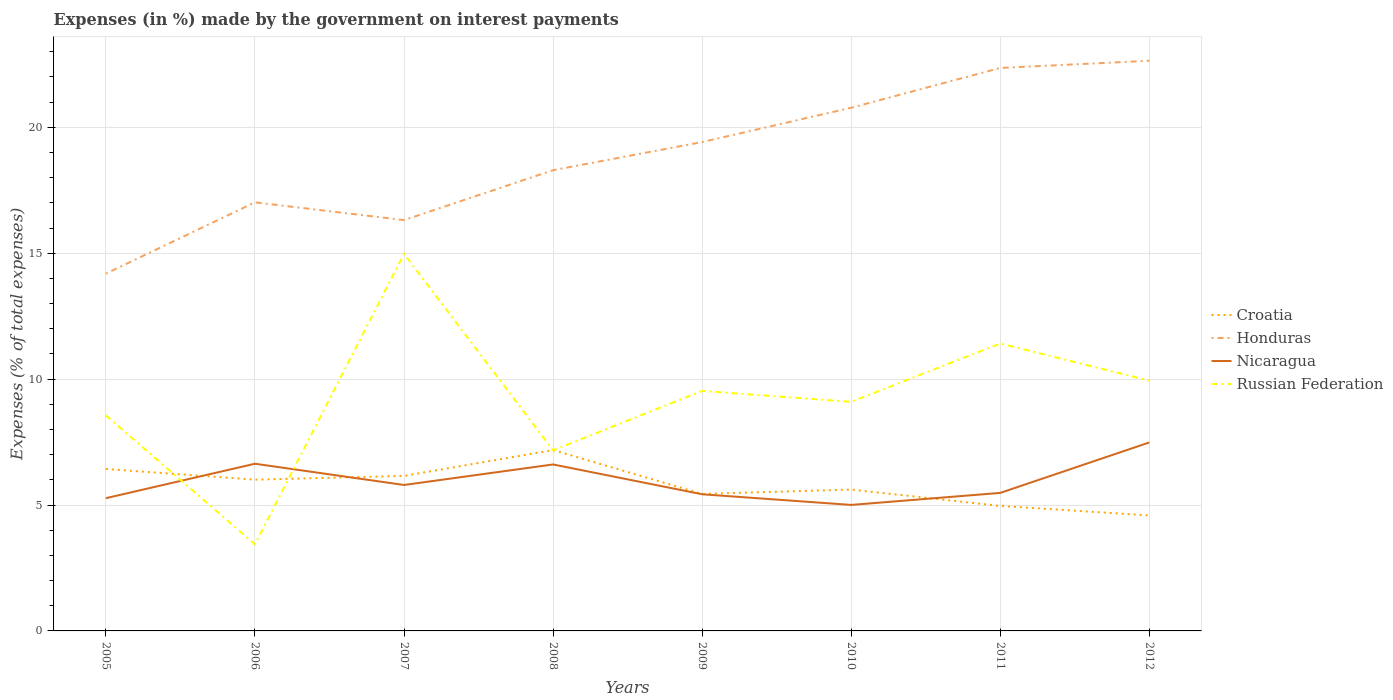How many different coloured lines are there?
Your response must be concise. 4. Is the number of lines equal to the number of legend labels?
Your answer should be compact. Yes. Across all years, what is the maximum percentage of expenses made by the government on interest payments in Croatia?
Ensure brevity in your answer.  4.59. What is the total percentage of expenses made by the government on interest payments in Honduras in the graph?
Your response must be concise. -4.06. What is the difference between the highest and the second highest percentage of expenses made by the government on interest payments in Croatia?
Offer a terse response. 2.6. What is the difference between the highest and the lowest percentage of expenses made by the government on interest payments in Honduras?
Offer a terse response. 4. Is the percentage of expenses made by the government on interest payments in Honduras strictly greater than the percentage of expenses made by the government on interest payments in Nicaragua over the years?
Your answer should be compact. No. How many lines are there?
Offer a terse response. 4. How many years are there in the graph?
Offer a terse response. 8. What is the difference between two consecutive major ticks on the Y-axis?
Offer a very short reply. 5. Are the values on the major ticks of Y-axis written in scientific E-notation?
Your response must be concise. No. How many legend labels are there?
Ensure brevity in your answer.  4. What is the title of the graph?
Make the answer very short. Expenses (in %) made by the government on interest payments. Does "Cuba" appear as one of the legend labels in the graph?
Give a very brief answer. No. What is the label or title of the Y-axis?
Your answer should be compact. Expenses (% of total expenses). What is the Expenses (% of total expenses) in Croatia in 2005?
Your answer should be very brief. 6.43. What is the Expenses (% of total expenses) of Honduras in 2005?
Your answer should be very brief. 14.19. What is the Expenses (% of total expenses) in Nicaragua in 2005?
Keep it short and to the point. 5.27. What is the Expenses (% of total expenses) of Russian Federation in 2005?
Your answer should be very brief. 8.56. What is the Expenses (% of total expenses) in Croatia in 2006?
Ensure brevity in your answer.  6.01. What is the Expenses (% of total expenses) of Honduras in 2006?
Provide a short and direct response. 17.02. What is the Expenses (% of total expenses) of Nicaragua in 2006?
Provide a succinct answer. 6.64. What is the Expenses (% of total expenses) in Russian Federation in 2006?
Your response must be concise. 3.44. What is the Expenses (% of total expenses) of Croatia in 2007?
Offer a terse response. 6.16. What is the Expenses (% of total expenses) in Honduras in 2007?
Offer a terse response. 16.32. What is the Expenses (% of total expenses) of Nicaragua in 2007?
Provide a short and direct response. 5.8. What is the Expenses (% of total expenses) in Russian Federation in 2007?
Your answer should be very brief. 14.98. What is the Expenses (% of total expenses) in Croatia in 2008?
Your answer should be compact. 7.18. What is the Expenses (% of total expenses) of Honduras in 2008?
Offer a terse response. 18.3. What is the Expenses (% of total expenses) of Nicaragua in 2008?
Your answer should be compact. 6.61. What is the Expenses (% of total expenses) in Russian Federation in 2008?
Give a very brief answer. 7.17. What is the Expenses (% of total expenses) of Croatia in 2009?
Your answer should be very brief. 5.44. What is the Expenses (% of total expenses) in Honduras in 2009?
Offer a very short reply. 19.42. What is the Expenses (% of total expenses) in Nicaragua in 2009?
Your response must be concise. 5.43. What is the Expenses (% of total expenses) in Russian Federation in 2009?
Keep it short and to the point. 9.53. What is the Expenses (% of total expenses) of Croatia in 2010?
Offer a terse response. 5.61. What is the Expenses (% of total expenses) of Honduras in 2010?
Offer a terse response. 20.78. What is the Expenses (% of total expenses) of Nicaragua in 2010?
Provide a short and direct response. 5. What is the Expenses (% of total expenses) in Russian Federation in 2010?
Give a very brief answer. 9.1. What is the Expenses (% of total expenses) in Croatia in 2011?
Offer a very short reply. 4.96. What is the Expenses (% of total expenses) in Honduras in 2011?
Provide a succinct answer. 22.36. What is the Expenses (% of total expenses) of Nicaragua in 2011?
Your answer should be compact. 5.48. What is the Expenses (% of total expenses) of Russian Federation in 2011?
Your answer should be compact. 11.41. What is the Expenses (% of total expenses) of Croatia in 2012?
Give a very brief answer. 4.59. What is the Expenses (% of total expenses) in Honduras in 2012?
Ensure brevity in your answer.  22.64. What is the Expenses (% of total expenses) in Nicaragua in 2012?
Offer a very short reply. 7.49. What is the Expenses (% of total expenses) in Russian Federation in 2012?
Keep it short and to the point. 9.94. Across all years, what is the maximum Expenses (% of total expenses) in Croatia?
Provide a succinct answer. 7.18. Across all years, what is the maximum Expenses (% of total expenses) of Honduras?
Give a very brief answer. 22.64. Across all years, what is the maximum Expenses (% of total expenses) of Nicaragua?
Give a very brief answer. 7.49. Across all years, what is the maximum Expenses (% of total expenses) of Russian Federation?
Offer a very short reply. 14.98. Across all years, what is the minimum Expenses (% of total expenses) of Croatia?
Make the answer very short. 4.59. Across all years, what is the minimum Expenses (% of total expenses) of Honduras?
Your response must be concise. 14.19. Across all years, what is the minimum Expenses (% of total expenses) of Nicaragua?
Ensure brevity in your answer.  5. Across all years, what is the minimum Expenses (% of total expenses) of Russian Federation?
Your answer should be compact. 3.44. What is the total Expenses (% of total expenses) of Croatia in the graph?
Give a very brief answer. 46.38. What is the total Expenses (% of total expenses) in Honduras in the graph?
Your answer should be compact. 151.02. What is the total Expenses (% of total expenses) of Nicaragua in the graph?
Offer a terse response. 47.72. What is the total Expenses (% of total expenses) in Russian Federation in the graph?
Ensure brevity in your answer.  74.13. What is the difference between the Expenses (% of total expenses) of Croatia in 2005 and that in 2006?
Make the answer very short. 0.42. What is the difference between the Expenses (% of total expenses) of Honduras in 2005 and that in 2006?
Provide a succinct answer. -2.83. What is the difference between the Expenses (% of total expenses) in Nicaragua in 2005 and that in 2006?
Your answer should be compact. -1.37. What is the difference between the Expenses (% of total expenses) in Russian Federation in 2005 and that in 2006?
Ensure brevity in your answer.  5.12. What is the difference between the Expenses (% of total expenses) in Croatia in 2005 and that in 2007?
Make the answer very short. 0.28. What is the difference between the Expenses (% of total expenses) of Honduras in 2005 and that in 2007?
Keep it short and to the point. -2.13. What is the difference between the Expenses (% of total expenses) of Nicaragua in 2005 and that in 2007?
Your answer should be very brief. -0.52. What is the difference between the Expenses (% of total expenses) of Russian Federation in 2005 and that in 2007?
Offer a terse response. -6.42. What is the difference between the Expenses (% of total expenses) of Croatia in 2005 and that in 2008?
Give a very brief answer. -0.75. What is the difference between the Expenses (% of total expenses) in Honduras in 2005 and that in 2008?
Ensure brevity in your answer.  -4.11. What is the difference between the Expenses (% of total expenses) in Nicaragua in 2005 and that in 2008?
Provide a succinct answer. -1.34. What is the difference between the Expenses (% of total expenses) in Russian Federation in 2005 and that in 2008?
Your response must be concise. 1.39. What is the difference between the Expenses (% of total expenses) of Honduras in 2005 and that in 2009?
Keep it short and to the point. -5.23. What is the difference between the Expenses (% of total expenses) of Nicaragua in 2005 and that in 2009?
Ensure brevity in your answer.  -0.15. What is the difference between the Expenses (% of total expenses) in Russian Federation in 2005 and that in 2009?
Keep it short and to the point. -0.97. What is the difference between the Expenses (% of total expenses) in Croatia in 2005 and that in 2010?
Ensure brevity in your answer.  0.82. What is the difference between the Expenses (% of total expenses) of Honduras in 2005 and that in 2010?
Keep it short and to the point. -6.59. What is the difference between the Expenses (% of total expenses) in Nicaragua in 2005 and that in 2010?
Ensure brevity in your answer.  0.27. What is the difference between the Expenses (% of total expenses) in Russian Federation in 2005 and that in 2010?
Make the answer very short. -0.54. What is the difference between the Expenses (% of total expenses) of Croatia in 2005 and that in 2011?
Provide a short and direct response. 1.47. What is the difference between the Expenses (% of total expenses) in Honduras in 2005 and that in 2011?
Offer a very short reply. -8.17. What is the difference between the Expenses (% of total expenses) in Nicaragua in 2005 and that in 2011?
Ensure brevity in your answer.  -0.21. What is the difference between the Expenses (% of total expenses) in Russian Federation in 2005 and that in 2011?
Your response must be concise. -2.86. What is the difference between the Expenses (% of total expenses) in Croatia in 2005 and that in 2012?
Give a very brief answer. 1.84. What is the difference between the Expenses (% of total expenses) of Honduras in 2005 and that in 2012?
Your response must be concise. -8.45. What is the difference between the Expenses (% of total expenses) of Nicaragua in 2005 and that in 2012?
Your response must be concise. -2.21. What is the difference between the Expenses (% of total expenses) in Russian Federation in 2005 and that in 2012?
Offer a terse response. -1.38. What is the difference between the Expenses (% of total expenses) of Croatia in 2006 and that in 2007?
Your response must be concise. -0.15. What is the difference between the Expenses (% of total expenses) in Honduras in 2006 and that in 2007?
Provide a succinct answer. 0.7. What is the difference between the Expenses (% of total expenses) of Nicaragua in 2006 and that in 2007?
Give a very brief answer. 0.84. What is the difference between the Expenses (% of total expenses) in Russian Federation in 2006 and that in 2007?
Provide a short and direct response. -11.54. What is the difference between the Expenses (% of total expenses) of Croatia in 2006 and that in 2008?
Your response must be concise. -1.18. What is the difference between the Expenses (% of total expenses) in Honduras in 2006 and that in 2008?
Offer a terse response. -1.28. What is the difference between the Expenses (% of total expenses) of Nicaragua in 2006 and that in 2008?
Ensure brevity in your answer.  0.03. What is the difference between the Expenses (% of total expenses) in Russian Federation in 2006 and that in 2008?
Keep it short and to the point. -3.73. What is the difference between the Expenses (% of total expenses) of Croatia in 2006 and that in 2009?
Your response must be concise. 0.57. What is the difference between the Expenses (% of total expenses) in Honduras in 2006 and that in 2009?
Provide a short and direct response. -2.39. What is the difference between the Expenses (% of total expenses) in Nicaragua in 2006 and that in 2009?
Your response must be concise. 1.21. What is the difference between the Expenses (% of total expenses) of Russian Federation in 2006 and that in 2009?
Provide a short and direct response. -6.09. What is the difference between the Expenses (% of total expenses) of Croatia in 2006 and that in 2010?
Your answer should be very brief. 0.39. What is the difference between the Expenses (% of total expenses) of Honduras in 2006 and that in 2010?
Give a very brief answer. -3.76. What is the difference between the Expenses (% of total expenses) in Nicaragua in 2006 and that in 2010?
Your response must be concise. 1.64. What is the difference between the Expenses (% of total expenses) of Russian Federation in 2006 and that in 2010?
Keep it short and to the point. -5.66. What is the difference between the Expenses (% of total expenses) in Croatia in 2006 and that in 2011?
Give a very brief answer. 1.04. What is the difference between the Expenses (% of total expenses) of Honduras in 2006 and that in 2011?
Provide a succinct answer. -5.34. What is the difference between the Expenses (% of total expenses) of Nicaragua in 2006 and that in 2011?
Provide a short and direct response. 1.16. What is the difference between the Expenses (% of total expenses) in Russian Federation in 2006 and that in 2011?
Make the answer very short. -7.97. What is the difference between the Expenses (% of total expenses) in Croatia in 2006 and that in 2012?
Your response must be concise. 1.42. What is the difference between the Expenses (% of total expenses) of Honduras in 2006 and that in 2012?
Keep it short and to the point. -5.62. What is the difference between the Expenses (% of total expenses) in Nicaragua in 2006 and that in 2012?
Keep it short and to the point. -0.85. What is the difference between the Expenses (% of total expenses) of Russian Federation in 2006 and that in 2012?
Provide a succinct answer. -6.5. What is the difference between the Expenses (% of total expenses) of Croatia in 2007 and that in 2008?
Make the answer very short. -1.03. What is the difference between the Expenses (% of total expenses) of Honduras in 2007 and that in 2008?
Your answer should be very brief. -1.98. What is the difference between the Expenses (% of total expenses) in Nicaragua in 2007 and that in 2008?
Keep it short and to the point. -0.81. What is the difference between the Expenses (% of total expenses) in Russian Federation in 2007 and that in 2008?
Keep it short and to the point. 7.8. What is the difference between the Expenses (% of total expenses) of Croatia in 2007 and that in 2009?
Provide a succinct answer. 0.72. What is the difference between the Expenses (% of total expenses) of Honduras in 2007 and that in 2009?
Provide a succinct answer. -3.1. What is the difference between the Expenses (% of total expenses) in Nicaragua in 2007 and that in 2009?
Your answer should be very brief. 0.37. What is the difference between the Expenses (% of total expenses) in Russian Federation in 2007 and that in 2009?
Offer a terse response. 5.44. What is the difference between the Expenses (% of total expenses) of Croatia in 2007 and that in 2010?
Make the answer very short. 0.54. What is the difference between the Expenses (% of total expenses) of Honduras in 2007 and that in 2010?
Your answer should be very brief. -4.46. What is the difference between the Expenses (% of total expenses) in Nicaragua in 2007 and that in 2010?
Give a very brief answer. 0.79. What is the difference between the Expenses (% of total expenses) in Russian Federation in 2007 and that in 2010?
Your response must be concise. 5.88. What is the difference between the Expenses (% of total expenses) of Croatia in 2007 and that in 2011?
Ensure brevity in your answer.  1.19. What is the difference between the Expenses (% of total expenses) in Honduras in 2007 and that in 2011?
Provide a succinct answer. -6.04. What is the difference between the Expenses (% of total expenses) of Nicaragua in 2007 and that in 2011?
Offer a very short reply. 0.31. What is the difference between the Expenses (% of total expenses) in Russian Federation in 2007 and that in 2011?
Offer a terse response. 3.56. What is the difference between the Expenses (% of total expenses) of Croatia in 2007 and that in 2012?
Keep it short and to the point. 1.57. What is the difference between the Expenses (% of total expenses) in Honduras in 2007 and that in 2012?
Your answer should be very brief. -6.33. What is the difference between the Expenses (% of total expenses) in Nicaragua in 2007 and that in 2012?
Make the answer very short. -1.69. What is the difference between the Expenses (% of total expenses) in Russian Federation in 2007 and that in 2012?
Offer a very short reply. 5.04. What is the difference between the Expenses (% of total expenses) in Croatia in 2008 and that in 2009?
Your answer should be very brief. 1.74. What is the difference between the Expenses (% of total expenses) of Honduras in 2008 and that in 2009?
Keep it short and to the point. -1.12. What is the difference between the Expenses (% of total expenses) of Nicaragua in 2008 and that in 2009?
Provide a succinct answer. 1.18. What is the difference between the Expenses (% of total expenses) in Russian Federation in 2008 and that in 2009?
Make the answer very short. -2.36. What is the difference between the Expenses (% of total expenses) in Croatia in 2008 and that in 2010?
Offer a very short reply. 1.57. What is the difference between the Expenses (% of total expenses) of Honduras in 2008 and that in 2010?
Provide a succinct answer. -2.48. What is the difference between the Expenses (% of total expenses) of Nicaragua in 2008 and that in 2010?
Keep it short and to the point. 1.61. What is the difference between the Expenses (% of total expenses) of Russian Federation in 2008 and that in 2010?
Provide a short and direct response. -1.93. What is the difference between the Expenses (% of total expenses) of Croatia in 2008 and that in 2011?
Your response must be concise. 2.22. What is the difference between the Expenses (% of total expenses) in Honduras in 2008 and that in 2011?
Provide a succinct answer. -4.06. What is the difference between the Expenses (% of total expenses) in Nicaragua in 2008 and that in 2011?
Provide a short and direct response. 1.13. What is the difference between the Expenses (% of total expenses) in Russian Federation in 2008 and that in 2011?
Your answer should be very brief. -4.24. What is the difference between the Expenses (% of total expenses) in Croatia in 2008 and that in 2012?
Give a very brief answer. 2.6. What is the difference between the Expenses (% of total expenses) of Honduras in 2008 and that in 2012?
Provide a succinct answer. -4.35. What is the difference between the Expenses (% of total expenses) in Nicaragua in 2008 and that in 2012?
Your response must be concise. -0.87. What is the difference between the Expenses (% of total expenses) in Russian Federation in 2008 and that in 2012?
Your response must be concise. -2.77. What is the difference between the Expenses (% of total expenses) in Croatia in 2009 and that in 2010?
Make the answer very short. -0.17. What is the difference between the Expenses (% of total expenses) in Honduras in 2009 and that in 2010?
Offer a very short reply. -1.36. What is the difference between the Expenses (% of total expenses) in Nicaragua in 2009 and that in 2010?
Ensure brevity in your answer.  0.42. What is the difference between the Expenses (% of total expenses) in Russian Federation in 2009 and that in 2010?
Offer a very short reply. 0.43. What is the difference between the Expenses (% of total expenses) of Croatia in 2009 and that in 2011?
Make the answer very short. 0.48. What is the difference between the Expenses (% of total expenses) of Honduras in 2009 and that in 2011?
Offer a very short reply. -2.94. What is the difference between the Expenses (% of total expenses) in Nicaragua in 2009 and that in 2011?
Offer a terse response. -0.05. What is the difference between the Expenses (% of total expenses) of Russian Federation in 2009 and that in 2011?
Offer a terse response. -1.88. What is the difference between the Expenses (% of total expenses) of Croatia in 2009 and that in 2012?
Ensure brevity in your answer.  0.85. What is the difference between the Expenses (% of total expenses) of Honduras in 2009 and that in 2012?
Provide a succinct answer. -3.23. What is the difference between the Expenses (% of total expenses) in Nicaragua in 2009 and that in 2012?
Offer a very short reply. -2.06. What is the difference between the Expenses (% of total expenses) of Russian Federation in 2009 and that in 2012?
Provide a succinct answer. -0.41. What is the difference between the Expenses (% of total expenses) of Croatia in 2010 and that in 2011?
Offer a terse response. 0.65. What is the difference between the Expenses (% of total expenses) in Honduras in 2010 and that in 2011?
Provide a short and direct response. -1.58. What is the difference between the Expenses (% of total expenses) of Nicaragua in 2010 and that in 2011?
Provide a short and direct response. -0.48. What is the difference between the Expenses (% of total expenses) in Russian Federation in 2010 and that in 2011?
Keep it short and to the point. -2.32. What is the difference between the Expenses (% of total expenses) of Croatia in 2010 and that in 2012?
Your response must be concise. 1.03. What is the difference between the Expenses (% of total expenses) of Honduras in 2010 and that in 2012?
Make the answer very short. -1.87. What is the difference between the Expenses (% of total expenses) in Nicaragua in 2010 and that in 2012?
Offer a very short reply. -2.48. What is the difference between the Expenses (% of total expenses) of Russian Federation in 2010 and that in 2012?
Your answer should be very brief. -0.84. What is the difference between the Expenses (% of total expenses) of Croatia in 2011 and that in 2012?
Your answer should be very brief. 0.38. What is the difference between the Expenses (% of total expenses) of Honduras in 2011 and that in 2012?
Offer a terse response. -0.29. What is the difference between the Expenses (% of total expenses) of Nicaragua in 2011 and that in 2012?
Provide a short and direct response. -2. What is the difference between the Expenses (% of total expenses) in Russian Federation in 2011 and that in 2012?
Keep it short and to the point. 1.48. What is the difference between the Expenses (% of total expenses) in Croatia in 2005 and the Expenses (% of total expenses) in Honduras in 2006?
Your answer should be compact. -10.59. What is the difference between the Expenses (% of total expenses) of Croatia in 2005 and the Expenses (% of total expenses) of Nicaragua in 2006?
Give a very brief answer. -0.21. What is the difference between the Expenses (% of total expenses) in Croatia in 2005 and the Expenses (% of total expenses) in Russian Federation in 2006?
Offer a very short reply. 2.99. What is the difference between the Expenses (% of total expenses) in Honduras in 2005 and the Expenses (% of total expenses) in Nicaragua in 2006?
Your answer should be very brief. 7.55. What is the difference between the Expenses (% of total expenses) of Honduras in 2005 and the Expenses (% of total expenses) of Russian Federation in 2006?
Your answer should be very brief. 10.75. What is the difference between the Expenses (% of total expenses) of Nicaragua in 2005 and the Expenses (% of total expenses) of Russian Federation in 2006?
Provide a succinct answer. 1.83. What is the difference between the Expenses (% of total expenses) in Croatia in 2005 and the Expenses (% of total expenses) in Honduras in 2007?
Your response must be concise. -9.88. What is the difference between the Expenses (% of total expenses) of Croatia in 2005 and the Expenses (% of total expenses) of Nicaragua in 2007?
Offer a very short reply. 0.64. What is the difference between the Expenses (% of total expenses) in Croatia in 2005 and the Expenses (% of total expenses) in Russian Federation in 2007?
Offer a very short reply. -8.54. What is the difference between the Expenses (% of total expenses) in Honduras in 2005 and the Expenses (% of total expenses) in Nicaragua in 2007?
Ensure brevity in your answer.  8.39. What is the difference between the Expenses (% of total expenses) of Honduras in 2005 and the Expenses (% of total expenses) of Russian Federation in 2007?
Your response must be concise. -0.79. What is the difference between the Expenses (% of total expenses) of Nicaragua in 2005 and the Expenses (% of total expenses) of Russian Federation in 2007?
Give a very brief answer. -9.7. What is the difference between the Expenses (% of total expenses) in Croatia in 2005 and the Expenses (% of total expenses) in Honduras in 2008?
Offer a very short reply. -11.87. What is the difference between the Expenses (% of total expenses) of Croatia in 2005 and the Expenses (% of total expenses) of Nicaragua in 2008?
Offer a terse response. -0.18. What is the difference between the Expenses (% of total expenses) in Croatia in 2005 and the Expenses (% of total expenses) in Russian Federation in 2008?
Keep it short and to the point. -0.74. What is the difference between the Expenses (% of total expenses) in Honduras in 2005 and the Expenses (% of total expenses) in Nicaragua in 2008?
Make the answer very short. 7.58. What is the difference between the Expenses (% of total expenses) in Honduras in 2005 and the Expenses (% of total expenses) in Russian Federation in 2008?
Offer a very short reply. 7.02. What is the difference between the Expenses (% of total expenses) of Nicaragua in 2005 and the Expenses (% of total expenses) of Russian Federation in 2008?
Your answer should be very brief. -1.9. What is the difference between the Expenses (% of total expenses) of Croatia in 2005 and the Expenses (% of total expenses) of Honduras in 2009?
Provide a succinct answer. -12.98. What is the difference between the Expenses (% of total expenses) of Croatia in 2005 and the Expenses (% of total expenses) of Russian Federation in 2009?
Ensure brevity in your answer.  -3.1. What is the difference between the Expenses (% of total expenses) in Honduras in 2005 and the Expenses (% of total expenses) in Nicaragua in 2009?
Provide a short and direct response. 8.76. What is the difference between the Expenses (% of total expenses) of Honduras in 2005 and the Expenses (% of total expenses) of Russian Federation in 2009?
Ensure brevity in your answer.  4.66. What is the difference between the Expenses (% of total expenses) in Nicaragua in 2005 and the Expenses (% of total expenses) in Russian Federation in 2009?
Keep it short and to the point. -4.26. What is the difference between the Expenses (% of total expenses) in Croatia in 2005 and the Expenses (% of total expenses) in Honduras in 2010?
Keep it short and to the point. -14.35. What is the difference between the Expenses (% of total expenses) in Croatia in 2005 and the Expenses (% of total expenses) in Nicaragua in 2010?
Give a very brief answer. 1.43. What is the difference between the Expenses (% of total expenses) in Croatia in 2005 and the Expenses (% of total expenses) in Russian Federation in 2010?
Provide a short and direct response. -2.67. What is the difference between the Expenses (% of total expenses) of Honduras in 2005 and the Expenses (% of total expenses) of Nicaragua in 2010?
Your answer should be compact. 9.19. What is the difference between the Expenses (% of total expenses) of Honduras in 2005 and the Expenses (% of total expenses) of Russian Federation in 2010?
Offer a terse response. 5.09. What is the difference between the Expenses (% of total expenses) of Nicaragua in 2005 and the Expenses (% of total expenses) of Russian Federation in 2010?
Your response must be concise. -3.83. What is the difference between the Expenses (% of total expenses) of Croatia in 2005 and the Expenses (% of total expenses) of Honduras in 2011?
Give a very brief answer. -15.93. What is the difference between the Expenses (% of total expenses) in Croatia in 2005 and the Expenses (% of total expenses) in Nicaragua in 2011?
Keep it short and to the point. 0.95. What is the difference between the Expenses (% of total expenses) in Croatia in 2005 and the Expenses (% of total expenses) in Russian Federation in 2011?
Make the answer very short. -4.98. What is the difference between the Expenses (% of total expenses) in Honduras in 2005 and the Expenses (% of total expenses) in Nicaragua in 2011?
Your response must be concise. 8.71. What is the difference between the Expenses (% of total expenses) of Honduras in 2005 and the Expenses (% of total expenses) of Russian Federation in 2011?
Offer a terse response. 2.78. What is the difference between the Expenses (% of total expenses) in Nicaragua in 2005 and the Expenses (% of total expenses) in Russian Federation in 2011?
Make the answer very short. -6.14. What is the difference between the Expenses (% of total expenses) in Croatia in 2005 and the Expenses (% of total expenses) in Honduras in 2012?
Provide a short and direct response. -16.21. What is the difference between the Expenses (% of total expenses) in Croatia in 2005 and the Expenses (% of total expenses) in Nicaragua in 2012?
Offer a terse response. -1.05. What is the difference between the Expenses (% of total expenses) of Croatia in 2005 and the Expenses (% of total expenses) of Russian Federation in 2012?
Provide a succinct answer. -3.51. What is the difference between the Expenses (% of total expenses) in Honduras in 2005 and the Expenses (% of total expenses) in Nicaragua in 2012?
Offer a terse response. 6.7. What is the difference between the Expenses (% of total expenses) of Honduras in 2005 and the Expenses (% of total expenses) of Russian Federation in 2012?
Provide a succinct answer. 4.25. What is the difference between the Expenses (% of total expenses) of Nicaragua in 2005 and the Expenses (% of total expenses) of Russian Federation in 2012?
Provide a short and direct response. -4.67. What is the difference between the Expenses (% of total expenses) of Croatia in 2006 and the Expenses (% of total expenses) of Honduras in 2007?
Make the answer very short. -10.31. What is the difference between the Expenses (% of total expenses) in Croatia in 2006 and the Expenses (% of total expenses) in Nicaragua in 2007?
Provide a short and direct response. 0.21. What is the difference between the Expenses (% of total expenses) in Croatia in 2006 and the Expenses (% of total expenses) in Russian Federation in 2007?
Offer a very short reply. -8.97. What is the difference between the Expenses (% of total expenses) in Honduras in 2006 and the Expenses (% of total expenses) in Nicaragua in 2007?
Make the answer very short. 11.22. What is the difference between the Expenses (% of total expenses) in Honduras in 2006 and the Expenses (% of total expenses) in Russian Federation in 2007?
Ensure brevity in your answer.  2.05. What is the difference between the Expenses (% of total expenses) in Nicaragua in 2006 and the Expenses (% of total expenses) in Russian Federation in 2007?
Offer a very short reply. -8.34. What is the difference between the Expenses (% of total expenses) in Croatia in 2006 and the Expenses (% of total expenses) in Honduras in 2008?
Provide a short and direct response. -12.29. What is the difference between the Expenses (% of total expenses) of Croatia in 2006 and the Expenses (% of total expenses) of Nicaragua in 2008?
Ensure brevity in your answer.  -0.6. What is the difference between the Expenses (% of total expenses) of Croatia in 2006 and the Expenses (% of total expenses) of Russian Federation in 2008?
Ensure brevity in your answer.  -1.17. What is the difference between the Expenses (% of total expenses) of Honduras in 2006 and the Expenses (% of total expenses) of Nicaragua in 2008?
Your response must be concise. 10.41. What is the difference between the Expenses (% of total expenses) of Honduras in 2006 and the Expenses (% of total expenses) of Russian Federation in 2008?
Make the answer very short. 9.85. What is the difference between the Expenses (% of total expenses) in Nicaragua in 2006 and the Expenses (% of total expenses) in Russian Federation in 2008?
Keep it short and to the point. -0.53. What is the difference between the Expenses (% of total expenses) in Croatia in 2006 and the Expenses (% of total expenses) in Honduras in 2009?
Keep it short and to the point. -13.41. What is the difference between the Expenses (% of total expenses) in Croatia in 2006 and the Expenses (% of total expenses) in Nicaragua in 2009?
Offer a very short reply. 0.58. What is the difference between the Expenses (% of total expenses) of Croatia in 2006 and the Expenses (% of total expenses) of Russian Federation in 2009?
Ensure brevity in your answer.  -3.53. What is the difference between the Expenses (% of total expenses) of Honduras in 2006 and the Expenses (% of total expenses) of Nicaragua in 2009?
Ensure brevity in your answer.  11.59. What is the difference between the Expenses (% of total expenses) in Honduras in 2006 and the Expenses (% of total expenses) in Russian Federation in 2009?
Keep it short and to the point. 7.49. What is the difference between the Expenses (% of total expenses) of Nicaragua in 2006 and the Expenses (% of total expenses) of Russian Federation in 2009?
Ensure brevity in your answer.  -2.89. What is the difference between the Expenses (% of total expenses) of Croatia in 2006 and the Expenses (% of total expenses) of Honduras in 2010?
Your response must be concise. -14.77. What is the difference between the Expenses (% of total expenses) in Croatia in 2006 and the Expenses (% of total expenses) in Nicaragua in 2010?
Ensure brevity in your answer.  1. What is the difference between the Expenses (% of total expenses) of Croatia in 2006 and the Expenses (% of total expenses) of Russian Federation in 2010?
Your answer should be compact. -3.09. What is the difference between the Expenses (% of total expenses) in Honduras in 2006 and the Expenses (% of total expenses) in Nicaragua in 2010?
Make the answer very short. 12.02. What is the difference between the Expenses (% of total expenses) of Honduras in 2006 and the Expenses (% of total expenses) of Russian Federation in 2010?
Your answer should be very brief. 7.92. What is the difference between the Expenses (% of total expenses) in Nicaragua in 2006 and the Expenses (% of total expenses) in Russian Federation in 2010?
Ensure brevity in your answer.  -2.46. What is the difference between the Expenses (% of total expenses) of Croatia in 2006 and the Expenses (% of total expenses) of Honduras in 2011?
Make the answer very short. -16.35. What is the difference between the Expenses (% of total expenses) in Croatia in 2006 and the Expenses (% of total expenses) in Nicaragua in 2011?
Provide a short and direct response. 0.53. What is the difference between the Expenses (% of total expenses) in Croatia in 2006 and the Expenses (% of total expenses) in Russian Federation in 2011?
Offer a very short reply. -5.41. What is the difference between the Expenses (% of total expenses) in Honduras in 2006 and the Expenses (% of total expenses) in Nicaragua in 2011?
Offer a terse response. 11.54. What is the difference between the Expenses (% of total expenses) in Honduras in 2006 and the Expenses (% of total expenses) in Russian Federation in 2011?
Make the answer very short. 5.61. What is the difference between the Expenses (% of total expenses) in Nicaragua in 2006 and the Expenses (% of total expenses) in Russian Federation in 2011?
Offer a terse response. -4.78. What is the difference between the Expenses (% of total expenses) in Croatia in 2006 and the Expenses (% of total expenses) in Honduras in 2012?
Provide a succinct answer. -16.64. What is the difference between the Expenses (% of total expenses) of Croatia in 2006 and the Expenses (% of total expenses) of Nicaragua in 2012?
Your answer should be compact. -1.48. What is the difference between the Expenses (% of total expenses) of Croatia in 2006 and the Expenses (% of total expenses) of Russian Federation in 2012?
Your answer should be very brief. -3.93. What is the difference between the Expenses (% of total expenses) in Honduras in 2006 and the Expenses (% of total expenses) in Nicaragua in 2012?
Provide a succinct answer. 9.54. What is the difference between the Expenses (% of total expenses) of Honduras in 2006 and the Expenses (% of total expenses) of Russian Federation in 2012?
Your answer should be very brief. 7.08. What is the difference between the Expenses (% of total expenses) of Nicaragua in 2006 and the Expenses (% of total expenses) of Russian Federation in 2012?
Ensure brevity in your answer.  -3.3. What is the difference between the Expenses (% of total expenses) in Croatia in 2007 and the Expenses (% of total expenses) in Honduras in 2008?
Your answer should be very brief. -12.14. What is the difference between the Expenses (% of total expenses) of Croatia in 2007 and the Expenses (% of total expenses) of Nicaragua in 2008?
Ensure brevity in your answer.  -0.45. What is the difference between the Expenses (% of total expenses) of Croatia in 2007 and the Expenses (% of total expenses) of Russian Federation in 2008?
Provide a succinct answer. -1.02. What is the difference between the Expenses (% of total expenses) of Honduras in 2007 and the Expenses (% of total expenses) of Nicaragua in 2008?
Provide a succinct answer. 9.71. What is the difference between the Expenses (% of total expenses) in Honduras in 2007 and the Expenses (% of total expenses) in Russian Federation in 2008?
Your answer should be very brief. 9.14. What is the difference between the Expenses (% of total expenses) in Nicaragua in 2007 and the Expenses (% of total expenses) in Russian Federation in 2008?
Ensure brevity in your answer.  -1.38. What is the difference between the Expenses (% of total expenses) in Croatia in 2007 and the Expenses (% of total expenses) in Honduras in 2009?
Provide a succinct answer. -13.26. What is the difference between the Expenses (% of total expenses) of Croatia in 2007 and the Expenses (% of total expenses) of Nicaragua in 2009?
Offer a very short reply. 0.73. What is the difference between the Expenses (% of total expenses) of Croatia in 2007 and the Expenses (% of total expenses) of Russian Federation in 2009?
Give a very brief answer. -3.38. What is the difference between the Expenses (% of total expenses) in Honduras in 2007 and the Expenses (% of total expenses) in Nicaragua in 2009?
Offer a terse response. 10.89. What is the difference between the Expenses (% of total expenses) in Honduras in 2007 and the Expenses (% of total expenses) in Russian Federation in 2009?
Make the answer very short. 6.78. What is the difference between the Expenses (% of total expenses) of Nicaragua in 2007 and the Expenses (% of total expenses) of Russian Federation in 2009?
Ensure brevity in your answer.  -3.74. What is the difference between the Expenses (% of total expenses) in Croatia in 2007 and the Expenses (% of total expenses) in Honduras in 2010?
Provide a succinct answer. -14.62. What is the difference between the Expenses (% of total expenses) of Croatia in 2007 and the Expenses (% of total expenses) of Nicaragua in 2010?
Provide a succinct answer. 1.15. What is the difference between the Expenses (% of total expenses) of Croatia in 2007 and the Expenses (% of total expenses) of Russian Federation in 2010?
Give a very brief answer. -2.94. What is the difference between the Expenses (% of total expenses) in Honduras in 2007 and the Expenses (% of total expenses) in Nicaragua in 2010?
Offer a terse response. 11.31. What is the difference between the Expenses (% of total expenses) in Honduras in 2007 and the Expenses (% of total expenses) in Russian Federation in 2010?
Offer a terse response. 7.22. What is the difference between the Expenses (% of total expenses) of Nicaragua in 2007 and the Expenses (% of total expenses) of Russian Federation in 2010?
Keep it short and to the point. -3.3. What is the difference between the Expenses (% of total expenses) of Croatia in 2007 and the Expenses (% of total expenses) of Honduras in 2011?
Provide a succinct answer. -16.2. What is the difference between the Expenses (% of total expenses) in Croatia in 2007 and the Expenses (% of total expenses) in Nicaragua in 2011?
Provide a succinct answer. 0.67. What is the difference between the Expenses (% of total expenses) of Croatia in 2007 and the Expenses (% of total expenses) of Russian Federation in 2011?
Your response must be concise. -5.26. What is the difference between the Expenses (% of total expenses) of Honduras in 2007 and the Expenses (% of total expenses) of Nicaragua in 2011?
Provide a short and direct response. 10.83. What is the difference between the Expenses (% of total expenses) in Honduras in 2007 and the Expenses (% of total expenses) in Russian Federation in 2011?
Your answer should be compact. 4.9. What is the difference between the Expenses (% of total expenses) of Nicaragua in 2007 and the Expenses (% of total expenses) of Russian Federation in 2011?
Your answer should be compact. -5.62. What is the difference between the Expenses (% of total expenses) of Croatia in 2007 and the Expenses (% of total expenses) of Honduras in 2012?
Your answer should be compact. -16.49. What is the difference between the Expenses (% of total expenses) in Croatia in 2007 and the Expenses (% of total expenses) in Nicaragua in 2012?
Your answer should be compact. -1.33. What is the difference between the Expenses (% of total expenses) in Croatia in 2007 and the Expenses (% of total expenses) in Russian Federation in 2012?
Provide a succinct answer. -3.78. What is the difference between the Expenses (% of total expenses) of Honduras in 2007 and the Expenses (% of total expenses) of Nicaragua in 2012?
Give a very brief answer. 8.83. What is the difference between the Expenses (% of total expenses) of Honduras in 2007 and the Expenses (% of total expenses) of Russian Federation in 2012?
Your answer should be compact. 6.38. What is the difference between the Expenses (% of total expenses) of Nicaragua in 2007 and the Expenses (% of total expenses) of Russian Federation in 2012?
Provide a short and direct response. -4.14. What is the difference between the Expenses (% of total expenses) in Croatia in 2008 and the Expenses (% of total expenses) in Honduras in 2009?
Offer a very short reply. -12.23. What is the difference between the Expenses (% of total expenses) in Croatia in 2008 and the Expenses (% of total expenses) in Nicaragua in 2009?
Provide a succinct answer. 1.76. What is the difference between the Expenses (% of total expenses) in Croatia in 2008 and the Expenses (% of total expenses) in Russian Federation in 2009?
Ensure brevity in your answer.  -2.35. What is the difference between the Expenses (% of total expenses) of Honduras in 2008 and the Expenses (% of total expenses) of Nicaragua in 2009?
Ensure brevity in your answer.  12.87. What is the difference between the Expenses (% of total expenses) in Honduras in 2008 and the Expenses (% of total expenses) in Russian Federation in 2009?
Provide a succinct answer. 8.77. What is the difference between the Expenses (% of total expenses) of Nicaragua in 2008 and the Expenses (% of total expenses) of Russian Federation in 2009?
Offer a very short reply. -2.92. What is the difference between the Expenses (% of total expenses) in Croatia in 2008 and the Expenses (% of total expenses) in Honduras in 2010?
Make the answer very short. -13.59. What is the difference between the Expenses (% of total expenses) of Croatia in 2008 and the Expenses (% of total expenses) of Nicaragua in 2010?
Make the answer very short. 2.18. What is the difference between the Expenses (% of total expenses) of Croatia in 2008 and the Expenses (% of total expenses) of Russian Federation in 2010?
Offer a very short reply. -1.91. What is the difference between the Expenses (% of total expenses) in Honduras in 2008 and the Expenses (% of total expenses) in Nicaragua in 2010?
Provide a succinct answer. 13.29. What is the difference between the Expenses (% of total expenses) of Honduras in 2008 and the Expenses (% of total expenses) of Russian Federation in 2010?
Provide a succinct answer. 9.2. What is the difference between the Expenses (% of total expenses) of Nicaragua in 2008 and the Expenses (% of total expenses) of Russian Federation in 2010?
Keep it short and to the point. -2.49. What is the difference between the Expenses (% of total expenses) of Croatia in 2008 and the Expenses (% of total expenses) of Honduras in 2011?
Offer a very short reply. -15.17. What is the difference between the Expenses (% of total expenses) of Croatia in 2008 and the Expenses (% of total expenses) of Nicaragua in 2011?
Offer a very short reply. 1.7. What is the difference between the Expenses (% of total expenses) of Croatia in 2008 and the Expenses (% of total expenses) of Russian Federation in 2011?
Keep it short and to the point. -4.23. What is the difference between the Expenses (% of total expenses) in Honduras in 2008 and the Expenses (% of total expenses) in Nicaragua in 2011?
Your answer should be compact. 12.82. What is the difference between the Expenses (% of total expenses) in Honduras in 2008 and the Expenses (% of total expenses) in Russian Federation in 2011?
Provide a succinct answer. 6.88. What is the difference between the Expenses (% of total expenses) in Nicaragua in 2008 and the Expenses (% of total expenses) in Russian Federation in 2011?
Keep it short and to the point. -4.8. What is the difference between the Expenses (% of total expenses) of Croatia in 2008 and the Expenses (% of total expenses) of Honduras in 2012?
Offer a terse response. -15.46. What is the difference between the Expenses (% of total expenses) in Croatia in 2008 and the Expenses (% of total expenses) in Nicaragua in 2012?
Provide a short and direct response. -0.3. What is the difference between the Expenses (% of total expenses) of Croatia in 2008 and the Expenses (% of total expenses) of Russian Federation in 2012?
Your answer should be compact. -2.75. What is the difference between the Expenses (% of total expenses) of Honduras in 2008 and the Expenses (% of total expenses) of Nicaragua in 2012?
Your response must be concise. 10.81. What is the difference between the Expenses (% of total expenses) in Honduras in 2008 and the Expenses (% of total expenses) in Russian Federation in 2012?
Provide a succinct answer. 8.36. What is the difference between the Expenses (% of total expenses) of Nicaragua in 2008 and the Expenses (% of total expenses) of Russian Federation in 2012?
Your response must be concise. -3.33. What is the difference between the Expenses (% of total expenses) of Croatia in 2009 and the Expenses (% of total expenses) of Honduras in 2010?
Offer a terse response. -15.34. What is the difference between the Expenses (% of total expenses) in Croatia in 2009 and the Expenses (% of total expenses) in Nicaragua in 2010?
Ensure brevity in your answer.  0.44. What is the difference between the Expenses (% of total expenses) of Croatia in 2009 and the Expenses (% of total expenses) of Russian Federation in 2010?
Give a very brief answer. -3.66. What is the difference between the Expenses (% of total expenses) of Honduras in 2009 and the Expenses (% of total expenses) of Nicaragua in 2010?
Your answer should be compact. 14.41. What is the difference between the Expenses (% of total expenses) in Honduras in 2009 and the Expenses (% of total expenses) in Russian Federation in 2010?
Give a very brief answer. 10.32. What is the difference between the Expenses (% of total expenses) of Nicaragua in 2009 and the Expenses (% of total expenses) of Russian Federation in 2010?
Give a very brief answer. -3.67. What is the difference between the Expenses (% of total expenses) of Croatia in 2009 and the Expenses (% of total expenses) of Honduras in 2011?
Give a very brief answer. -16.92. What is the difference between the Expenses (% of total expenses) of Croatia in 2009 and the Expenses (% of total expenses) of Nicaragua in 2011?
Your answer should be compact. -0.04. What is the difference between the Expenses (% of total expenses) in Croatia in 2009 and the Expenses (% of total expenses) in Russian Federation in 2011?
Provide a succinct answer. -5.97. What is the difference between the Expenses (% of total expenses) of Honduras in 2009 and the Expenses (% of total expenses) of Nicaragua in 2011?
Make the answer very short. 13.93. What is the difference between the Expenses (% of total expenses) in Honduras in 2009 and the Expenses (% of total expenses) in Russian Federation in 2011?
Your answer should be compact. 8. What is the difference between the Expenses (% of total expenses) of Nicaragua in 2009 and the Expenses (% of total expenses) of Russian Federation in 2011?
Offer a terse response. -5.99. What is the difference between the Expenses (% of total expenses) in Croatia in 2009 and the Expenses (% of total expenses) in Honduras in 2012?
Offer a very short reply. -17.2. What is the difference between the Expenses (% of total expenses) of Croatia in 2009 and the Expenses (% of total expenses) of Nicaragua in 2012?
Offer a very short reply. -2.05. What is the difference between the Expenses (% of total expenses) of Croatia in 2009 and the Expenses (% of total expenses) of Russian Federation in 2012?
Your answer should be very brief. -4.5. What is the difference between the Expenses (% of total expenses) of Honduras in 2009 and the Expenses (% of total expenses) of Nicaragua in 2012?
Provide a short and direct response. 11.93. What is the difference between the Expenses (% of total expenses) in Honduras in 2009 and the Expenses (% of total expenses) in Russian Federation in 2012?
Provide a succinct answer. 9.48. What is the difference between the Expenses (% of total expenses) in Nicaragua in 2009 and the Expenses (% of total expenses) in Russian Federation in 2012?
Make the answer very short. -4.51. What is the difference between the Expenses (% of total expenses) in Croatia in 2010 and the Expenses (% of total expenses) in Honduras in 2011?
Give a very brief answer. -16.74. What is the difference between the Expenses (% of total expenses) of Croatia in 2010 and the Expenses (% of total expenses) of Nicaragua in 2011?
Ensure brevity in your answer.  0.13. What is the difference between the Expenses (% of total expenses) of Croatia in 2010 and the Expenses (% of total expenses) of Russian Federation in 2011?
Provide a short and direct response. -5.8. What is the difference between the Expenses (% of total expenses) in Honduras in 2010 and the Expenses (% of total expenses) in Nicaragua in 2011?
Give a very brief answer. 15.3. What is the difference between the Expenses (% of total expenses) in Honduras in 2010 and the Expenses (% of total expenses) in Russian Federation in 2011?
Your answer should be very brief. 9.36. What is the difference between the Expenses (% of total expenses) of Nicaragua in 2010 and the Expenses (% of total expenses) of Russian Federation in 2011?
Provide a succinct answer. -6.41. What is the difference between the Expenses (% of total expenses) of Croatia in 2010 and the Expenses (% of total expenses) of Honduras in 2012?
Make the answer very short. -17.03. What is the difference between the Expenses (% of total expenses) in Croatia in 2010 and the Expenses (% of total expenses) in Nicaragua in 2012?
Keep it short and to the point. -1.87. What is the difference between the Expenses (% of total expenses) in Croatia in 2010 and the Expenses (% of total expenses) in Russian Federation in 2012?
Your response must be concise. -4.32. What is the difference between the Expenses (% of total expenses) of Honduras in 2010 and the Expenses (% of total expenses) of Nicaragua in 2012?
Give a very brief answer. 13.29. What is the difference between the Expenses (% of total expenses) in Honduras in 2010 and the Expenses (% of total expenses) in Russian Federation in 2012?
Provide a succinct answer. 10.84. What is the difference between the Expenses (% of total expenses) in Nicaragua in 2010 and the Expenses (% of total expenses) in Russian Federation in 2012?
Give a very brief answer. -4.93. What is the difference between the Expenses (% of total expenses) in Croatia in 2011 and the Expenses (% of total expenses) in Honduras in 2012?
Keep it short and to the point. -17.68. What is the difference between the Expenses (% of total expenses) in Croatia in 2011 and the Expenses (% of total expenses) in Nicaragua in 2012?
Your answer should be very brief. -2.52. What is the difference between the Expenses (% of total expenses) of Croatia in 2011 and the Expenses (% of total expenses) of Russian Federation in 2012?
Keep it short and to the point. -4.97. What is the difference between the Expenses (% of total expenses) in Honduras in 2011 and the Expenses (% of total expenses) in Nicaragua in 2012?
Provide a succinct answer. 14.87. What is the difference between the Expenses (% of total expenses) of Honduras in 2011 and the Expenses (% of total expenses) of Russian Federation in 2012?
Make the answer very short. 12.42. What is the difference between the Expenses (% of total expenses) of Nicaragua in 2011 and the Expenses (% of total expenses) of Russian Federation in 2012?
Offer a very short reply. -4.46. What is the average Expenses (% of total expenses) in Croatia per year?
Offer a very short reply. 5.8. What is the average Expenses (% of total expenses) in Honduras per year?
Offer a very short reply. 18.88. What is the average Expenses (% of total expenses) in Nicaragua per year?
Ensure brevity in your answer.  5.96. What is the average Expenses (% of total expenses) of Russian Federation per year?
Keep it short and to the point. 9.27. In the year 2005, what is the difference between the Expenses (% of total expenses) of Croatia and Expenses (% of total expenses) of Honduras?
Keep it short and to the point. -7.76. In the year 2005, what is the difference between the Expenses (% of total expenses) in Croatia and Expenses (% of total expenses) in Nicaragua?
Your response must be concise. 1.16. In the year 2005, what is the difference between the Expenses (% of total expenses) in Croatia and Expenses (% of total expenses) in Russian Federation?
Give a very brief answer. -2.13. In the year 2005, what is the difference between the Expenses (% of total expenses) in Honduras and Expenses (% of total expenses) in Nicaragua?
Offer a terse response. 8.92. In the year 2005, what is the difference between the Expenses (% of total expenses) of Honduras and Expenses (% of total expenses) of Russian Federation?
Keep it short and to the point. 5.63. In the year 2005, what is the difference between the Expenses (% of total expenses) in Nicaragua and Expenses (% of total expenses) in Russian Federation?
Offer a very short reply. -3.29. In the year 2006, what is the difference between the Expenses (% of total expenses) in Croatia and Expenses (% of total expenses) in Honduras?
Your response must be concise. -11.01. In the year 2006, what is the difference between the Expenses (% of total expenses) of Croatia and Expenses (% of total expenses) of Nicaragua?
Keep it short and to the point. -0.63. In the year 2006, what is the difference between the Expenses (% of total expenses) in Croatia and Expenses (% of total expenses) in Russian Federation?
Offer a terse response. 2.57. In the year 2006, what is the difference between the Expenses (% of total expenses) in Honduras and Expenses (% of total expenses) in Nicaragua?
Make the answer very short. 10.38. In the year 2006, what is the difference between the Expenses (% of total expenses) in Honduras and Expenses (% of total expenses) in Russian Federation?
Your answer should be very brief. 13.58. In the year 2006, what is the difference between the Expenses (% of total expenses) in Nicaragua and Expenses (% of total expenses) in Russian Federation?
Ensure brevity in your answer.  3.2. In the year 2007, what is the difference between the Expenses (% of total expenses) in Croatia and Expenses (% of total expenses) in Honduras?
Offer a very short reply. -10.16. In the year 2007, what is the difference between the Expenses (% of total expenses) of Croatia and Expenses (% of total expenses) of Nicaragua?
Provide a short and direct response. 0.36. In the year 2007, what is the difference between the Expenses (% of total expenses) of Croatia and Expenses (% of total expenses) of Russian Federation?
Ensure brevity in your answer.  -8.82. In the year 2007, what is the difference between the Expenses (% of total expenses) in Honduras and Expenses (% of total expenses) in Nicaragua?
Your answer should be compact. 10.52. In the year 2007, what is the difference between the Expenses (% of total expenses) of Honduras and Expenses (% of total expenses) of Russian Federation?
Offer a very short reply. 1.34. In the year 2007, what is the difference between the Expenses (% of total expenses) of Nicaragua and Expenses (% of total expenses) of Russian Federation?
Provide a succinct answer. -9.18. In the year 2008, what is the difference between the Expenses (% of total expenses) in Croatia and Expenses (% of total expenses) in Honduras?
Your answer should be very brief. -11.11. In the year 2008, what is the difference between the Expenses (% of total expenses) in Croatia and Expenses (% of total expenses) in Nicaragua?
Give a very brief answer. 0.57. In the year 2008, what is the difference between the Expenses (% of total expenses) of Croatia and Expenses (% of total expenses) of Russian Federation?
Provide a succinct answer. 0.01. In the year 2008, what is the difference between the Expenses (% of total expenses) of Honduras and Expenses (% of total expenses) of Nicaragua?
Give a very brief answer. 11.69. In the year 2008, what is the difference between the Expenses (% of total expenses) of Honduras and Expenses (% of total expenses) of Russian Federation?
Provide a short and direct response. 11.12. In the year 2008, what is the difference between the Expenses (% of total expenses) in Nicaragua and Expenses (% of total expenses) in Russian Federation?
Your answer should be very brief. -0.56. In the year 2009, what is the difference between the Expenses (% of total expenses) of Croatia and Expenses (% of total expenses) of Honduras?
Ensure brevity in your answer.  -13.97. In the year 2009, what is the difference between the Expenses (% of total expenses) of Croatia and Expenses (% of total expenses) of Nicaragua?
Ensure brevity in your answer.  0.01. In the year 2009, what is the difference between the Expenses (% of total expenses) of Croatia and Expenses (% of total expenses) of Russian Federation?
Your answer should be compact. -4.09. In the year 2009, what is the difference between the Expenses (% of total expenses) of Honduras and Expenses (% of total expenses) of Nicaragua?
Your response must be concise. 13.99. In the year 2009, what is the difference between the Expenses (% of total expenses) of Honduras and Expenses (% of total expenses) of Russian Federation?
Make the answer very short. 9.88. In the year 2009, what is the difference between the Expenses (% of total expenses) of Nicaragua and Expenses (% of total expenses) of Russian Federation?
Offer a terse response. -4.11. In the year 2010, what is the difference between the Expenses (% of total expenses) in Croatia and Expenses (% of total expenses) in Honduras?
Ensure brevity in your answer.  -15.16. In the year 2010, what is the difference between the Expenses (% of total expenses) in Croatia and Expenses (% of total expenses) in Nicaragua?
Offer a terse response. 0.61. In the year 2010, what is the difference between the Expenses (% of total expenses) in Croatia and Expenses (% of total expenses) in Russian Federation?
Provide a succinct answer. -3.48. In the year 2010, what is the difference between the Expenses (% of total expenses) in Honduras and Expenses (% of total expenses) in Nicaragua?
Ensure brevity in your answer.  15.77. In the year 2010, what is the difference between the Expenses (% of total expenses) in Honduras and Expenses (% of total expenses) in Russian Federation?
Your response must be concise. 11.68. In the year 2010, what is the difference between the Expenses (% of total expenses) of Nicaragua and Expenses (% of total expenses) of Russian Federation?
Your answer should be compact. -4.09. In the year 2011, what is the difference between the Expenses (% of total expenses) in Croatia and Expenses (% of total expenses) in Honduras?
Give a very brief answer. -17.39. In the year 2011, what is the difference between the Expenses (% of total expenses) in Croatia and Expenses (% of total expenses) in Nicaragua?
Your response must be concise. -0.52. In the year 2011, what is the difference between the Expenses (% of total expenses) of Croatia and Expenses (% of total expenses) of Russian Federation?
Offer a very short reply. -6.45. In the year 2011, what is the difference between the Expenses (% of total expenses) of Honduras and Expenses (% of total expenses) of Nicaragua?
Make the answer very short. 16.88. In the year 2011, what is the difference between the Expenses (% of total expenses) in Honduras and Expenses (% of total expenses) in Russian Federation?
Keep it short and to the point. 10.94. In the year 2011, what is the difference between the Expenses (% of total expenses) of Nicaragua and Expenses (% of total expenses) of Russian Federation?
Your answer should be compact. -5.93. In the year 2012, what is the difference between the Expenses (% of total expenses) of Croatia and Expenses (% of total expenses) of Honduras?
Provide a short and direct response. -18.06. In the year 2012, what is the difference between the Expenses (% of total expenses) in Croatia and Expenses (% of total expenses) in Nicaragua?
Offer a very short reply. -2.9. In the year 2012, what is the difference between the Expenses (% of total expenses) in Croatia and Expenses (% of total expenses) in Russian Federation?
Your answer should be compact. -5.35. In the year 2012, what is the difference between the Expenses (% of total expenses) of Honduras and Expenses (% of total expenses) of Nicaragua?
Provide a succinct answer. 15.16. In the year 2012, what is the difference between the Expenses (% of total expenses) of Honduras and Expenses (% of total expenses) of Russian Federation?
Provide a short and direct response. 12.71. In the year 2012, what is the difference between the Expenses (% of total expenses) of Nicaragua and Expenses (% of total expenses) of Russian Federation?
Offer a terse response. -2.45. What is the ratio of the Expenses (% of total expenses) in Croatia in 2005 to that in 2006?
Your answer should be very brief. 1.07. What is the ratio of the Expenses (% of total expenses) of Honduras in 2005 to that in 2006?
Your answer should be compact. 0.83. What is the ratio of the Expenses (% of total expenses) in Nicaragua in 2005 to that in 2006?
Provide a short and direct response. 0.79. What is the ratio of the Expenses (% of total expenses) of Russian Federation in 2005 to that in 2006?
Your answer should be very brief. 2.49. What is the ratio of the Expenses (% of total expenses) of Croatia in 2005 to that in 2007?
Offer a terse response. 1.04. What is the ratio of the Expenses (% of total expenses) in Honduras in 2005 to that in 2007?
Offer a terse response. 0.87. What is the ratio of the Expenses (% of total expenses) in Nicaragua in 2005 to that in 2007?
Your answer should be compact. 0.91. What is the ratio of the Expenses (% of total expenses) of Russian Federation in 2005 to that in 2007?
Your response must be concise. 0.57. What is the ratio of the Expenses (% of total expenses) in Croatia in 2005 to that in 2008?
Your answer should be very brief. 0.9. What is the ratio of the Expenses (% of total expenses) in Honduras in 2005 to that in 2008?
Your answer should be compact. 0.78. What is the ratio of the Expenses (% of total expenses) of Nicaragua in 2005 to that in 2008?
Provide a short and direct response. 0.8. What is the ratio of the Expenses (% of total expenses) of Russian Federation in 2005 to that in 2008?
Provide a succinct answer. 1.19. What is the ratio of the Expenses (% of total expenses) of Croatia in 2005 to that in 2009?
Make the answer very short. 1.18. What is the ratio of the Expenses (% of total expenses) of Honduras in 2005 to that in 2009?
Provide a short and direct response. 0.73. What is the ratio of the Expenses (% of total expenses) in Nicaragua in 2005 to that in 2009?
Give a very brief answer. 0.97. What is the ratio of the Expenses (% of total expenses) in Russian Federation in 2005 to that in 2009?
Your answer should be very brief. 0.9. What is the ratio of the Expenses (% of total expenses) of Croatia in 2005 to that in 2010?
Your response must be concise. 1.15. What is the ratio of the Expenses (% of total expenses) in Honduras in 2005 to that in 2010?
Provide a succinct answer. 0.68. What is the ratio of the Expenses (% of total expenses) in Nicaragua in 2005 to that in 2010?
Offer a very short reply. 1.05. What is the ratio of the Expenses (% of total expenses) of Russian Federation in 2005 to that in 2010?
Your answer should be very brief. 0.94. What is the ratio of the Expenses (% of total expenses) of Croatia in 2005 to that in 2011?
Keep it short and to the point. 1.3. What is the ratio of the Expenses (% of total expenses) in Honduras in 2005 to that in 2011?
Keep it short and to the point. 0.63. What is the ratio of the Expenses (% of total expenses) in Nicaragua in 2005 to that in 2011?
Your response must be concise. 0.96. What is the ratio of the Expenses (% of total expenses) of Russian Federation in 2005 to that in 2011?
Provide a short and direct response. 0.75. What is the ratio of the Expenses (% of total expenses) of Croatia in 2005 to that in 2012?
Provide a succinct answer. 1.4. What is the ratio of the Expenses (% of total expenses) in Honduras in 2005 to that in 2012?
Your answer should be very brief. 0.63. What is the ratio of the Expenses (% of total expenses) of Nicaragua in 2005 to that in 2012?
Provide a short and direct response. 0.7. What is the ratio of the Expenses (% of total expenses) in Russian Federation in 2005 to that in 2012?
Your answer should be very brief. 0.86. What is the ratio of the Expenses (% of total expenses) in Croatia in 2006 to that in 2007?
Your answer should be very brief. 0.98. What is the ratio of the Expenses (% of total expenses) in Honduras in 2006 to that in 2007?
Make the answer very short. 1.04. What is the ratio of the Expenses (% of total expenses) of Nicaragua in 2006 to that in 2007?
Offer a very short reply. 1.15. What is the ratio of the Expenses (% of total expenses) of Russian Federation in 2006 to that in 2007?
Provide a succinct answer. 0.23. What is the ratio of the Expenses (% of total expenses) of Croatia in 2006 to that in 2008?
Your answer should be very brief. 0.84. What is the ratio of the Expenses (% of total expenses) of Honduras in 2006 to that in 2008?
Make the answer very short. 0.93. What is the ratio of the Expenses (% of total expenses) in Nicaragua in 2006 to that in 2008?
Provide a short and direct response. 1. What is the ratio of the Expenses (% of total expenses) of Russian Federation in 2006 to that in 2008?
Give a very brief answer. 0.48. What is the ratio of the Expenses (% of total expenses) in Croatia in 2006 to that in 2009?
Ensure brevity in your answer.  1.1. What is the ratio of the Expenses (% of total expenses) of Honduras in 2006 to that in 2009?
Make the answer very short. 0.88. What is the ratio of the Expenses (% of total expenses) of Nicaragua in 2006 to that in 2009?
Make the answer very short. 1.22. What is the ratio of the Expenses (% of total expenses) of Russian Federation in 2006 to that in 2009?
Provide a short and direct response. 0.36. What is the ratio of the Expenses (% of total expenses) in Croatia in 2006 to that in 2010?
Provide a short and direct response. 1.07. What is the ratio of the Expenses (% of total expenses) of Honduras in 2006 to that in 2010?
Give a very brief answer. 0.82. What is the ratio of the Expenses (% of total expenses) in Nicaragua in 2006 to that in 2010?
Keep it short and to the point. 1.33. What is the ratio of the Expenses (% of total expenses) in Russian Federation in 2006 to that in 2010?
Your answer should be compact. 0.38. What is the ratio of the Expenses (% of total expenses) in Croatia in 2006 to that in 2011?
Your answer should be very brief. 1.21. What is the ratio of the Expenses (% of total expenses) in Honduras in 2006 to that in 2011?
Provide a short and direct response. 0.76. What is the ratio of the Expenses (% of total expenses) in Nicaragua in 2006 to that in 2011?
Keep it short and to the point. 1.21. What is the ratio of the Expenses (% of total expenses) in Russian Federation in 2006 to that in 2011?
Give a very brief answer. 0.3. What is the ratio of the Expenses (% of total expenses) of Croatia in 2006 to that in 2012?
Your answer should be compact. 1.31. What is the ratio of the Expenses (% of total expenses) of Honduras in 2006 to that in 2012?
Provide a short and direct response. 0.75. What is the ratio of the Expenses (% of total expenses) of Nicaragua in 2006 to that in 2012?
Your answer should be compact. 0.89. What is the ratio of the Expenses (% of total expenses) in Russian Federation in 2006 to that in 2012?
Give a very brief answer. 0.35. What is the ratio of the Expenses (% of total expenses) of Croatia in 2007 to that in 2008?
Ensure brevity in your answer.  0.86. What is the ratio of the Expenses (% of total expenses) in Honduras in 2007 to that in 2008?
Offer a very short reply. 0.89. What is the ratio of the Expenses (% of total expenses) in Nicaragua in 2007 to that in 2008?
Provide a succinct answer. 0.88. What is the ratio of the Expenses (% of total expenses) in Russian Federation in 2007 to that in 2008?
Ensure brevity in your answer.  2.09. What is the ratio of the Expenses (% of total expenses) in Croatia in 2007 to that in 2009?
Make the answer very short. 1.13. What is the ratio of the Expenses (% of total expenses) in Honduras in 2007 to that in 2009?
Keep it short and to the point. 0.84. What is the ratio of the Expenses (% of total expenses) in Nicaragua in 2007 to that in 2009?
Offer a very short reply. 1.07. What is the ratio of the Expenses (% of total expenses) of Russian Federation in 2007 to that in 2009?
Ensure brevity in your answer.  1.57. What is the ratio of the Expenses (% of total expenses) in Croatia in 2007 to that in 2010?
Ensure brevity in your answer.  1.1. What is the ratio of the Expenses (% of total expenses) in Honduras in 2007 to that in 2010?
Ensure brevity in your answer.  0.79. What is the ratio of the Expenses (% of total expenses) in Nicaragua in 2007 to that in 2010?
Ensure brevity in your answer.  1.16. What is the ratio of the Expenses (% of total expenses) of Russian Federation in 2007 to that in 2010?
Make the answer very short. 1.65. What is the ratio of the Expenses (% of total expenses) of Croatia in 2007 to that in 2011?
Your response must be concise. 1.24. What is the ratio of the Expenses (% of total expenses) in Honduras in 2007 to that in 2011?
Give a very brief answer. 0.73. What is the ratio of the Expenses (% of total expenses) of Nicaragua in 2007 to that in 2011?
Make the answer very short. 1.06. What is the ratio of the Expenses (% of total expenses) in Russian Federation in 2007 to that in 2011?
Ensure brevity in your answer.  1.31. What is the ratio of the Expenses (% of total expenses) of Croatia in 2007 to that in 2012?
Your answer should be very brief. 1.34. What is the ratio of the Expenses (% of total expenses) of Honduras in 2007 to that in 2012?
Offer a terse response. 0.72. What is the ratio of the Expenses (% of total expenses) in Nicaragua in 2007 to that in 2012?
Offer a terse response. 0.77. What is the ratio of the Expenses (% of total expenses) of Russian Federation in 2007 to that in 2012?
Ensure brevity in your answer.  1.51. What is the ratio of the Expenses (% of total expenses) of Croatia in 2008 to that in 2009?
Your answer should be very brief. 1.32. What is the ratio of the Expenses (% of total expenses) in Honduras in 2008 to that in 2009?
Your answer should be very brief. 0.94. What is the ratio of the Expenses (% of total expenses) in Nicaragua in 2008 to that in 2009?
Give a very brief answer. 1.22. What is the ratio of the Expenses (% of total expenses) in Russian Federation in 2008 to that in 2009?
Provide a short and direct response. 0.75. What is the ratio of the Expenses (% of total expenses) of Croatia in 2008 to that in 2010?
Your response must be concise. 1.28. What is the ratio of the Expenses (% of total expenses) in Honduras in 2008 to that in 2010?
Make the answer very short. 0.88. What is the ratio of the Expenses (% of total expenses) in Nicaragua in 2008 to that in 2010?
Your response must be concise. 1.32. What is the ratio of the Expenses (% of total expenses) of Russian Federation in 2008 to that in 2010?
Provide a succinct answer. 0.79. What is the ratio of the Expenses (% of total expenses) in Croatia in 2008 to that in 2011?
Provide a succinct answer. 1.45. What is the ratio of the Expenses (% of total expenses) of Honduras in 2008 to that in 2011?
Offer a very short reply. 0.82. What is the ratio of the Expenses (% of total expenses) of Nicaragua in 2008 to that in 2011?
Your answer should be very brief. 1.21. What is the ratio of the Expenses (% of total expenses) in Russian Federation in 2008 to that in 2011?
Offer a terse response. 0.63. What is the ratio of the Expenses (% of total expenses) in Croatia in 2008 to that in 2012?
Offer a terse response. 1.57. What is the ratio of the Expenses (% of total expenses) of Honduras in 2008 to that in 2012?
Provide a short and direct response. 0.81. What is the ratio of the Expenses (% of total expenses) in Nicaragua in 2008 to that in 2012?
Offer a very short reply. 0.88. What is the ratio of the Expenses (% of total expenses) in Russian Federation in 2008 to that in 2012?
Ensure brevity in your answer.  0.72. What is the ratio of the Expenses (% of total expenses) in Croatia in 2009 to that in 2010?
Your answer should be compact. 0.97. What is the ratio of the Expenses (% of total expenses) in Honduras in 2009 to that in 2010?
Give a very brief answer. 0.93. What is the ratio of the Expenses (% of total expenses) in Nicaragua in 2009 to that in 2010?
Offer a terse response. 1.08. What is the ratio of the Expenses (% of total expenses) in Russian Federation in 2009 to that in 2010?
Your answer should be compact. 1.05. What is the ratio of the Expenses (% of total expenses) of Croatia in 2009 to that in 2011?
Offer a terse response. 1.1. What is the ratio of the Expenses (% of total expenses) in Honduras in 2009 to that in 2011?
Ensure brevity in your answer.  0.87. What is the ratio of the Expenses (% of total expenses) in Nicaragua in 2009 to that in 2011?
Give a very brief answer. 0.99. What is the ratio of the Expenses (% of total expenses) in Russian Federation in 2009 to that in 2011?
Provide a short and direct response. 0.84. What is the ratio of the Expenses (% of total expenses) in Croatia in 2009 to that in 2012?
Keep it short and to the point. 1.19. What is the ratio of the Expenses (% of total expenses) in Honduras in 2009 to that in 2012?
Your response must be concise. 0.86. What is the ratio of the Expenses (% of total expenses) in Nicaragua in 2009 to that in 2012?
Your response must be concise. 0.72. What is the ratio of the Expenses (% of total expenses) in Russian Federation in 2009 to that in 2012?
Your answer should be compact. 0.96. What is the ratio of the Expenses (% of total expenses) of Croatia in 2010 to that in 2011?
Offer a terse response. 1.13. What is the ratio of the Expenses (% of total expenses) of Honduras in 2010 to that in 2011?
Make the answer very short. 0.93. What is the ratio of the Expenses (% of total expenses) in Nicaragua in 2010 to that in 2011?
Make the answer very short. 0.91. What is the ratio of the Expenses (% of total expenses) of Russian Federation in 2010 to that in 2011?
Your answer should be compact. 0.8. What is the ratio of the Expenses (% of total expenses) of Croatia in 2010 to that in 2012?
Ensure brevity in your answer.  1.22. What is the ratio of the Expenses (% of total expenses) in Honduras in 2010 to that in 2012?
Your answer should be very brief. 0.92. What is the ratio of the Expenses (% of total expenses) in Nicaragua in 2010 to that in 2012?
Keep it short and to the point. 0.67. What is the ratio of the Expenses (% of total expenses) of Russian Federation in 2010 to that in 2012?
Your response must be concise. 0.92. What is the ratio of the Expenses (% of total expenses) in Croatia in 2011 to that in 2012?
Your answer should be very brief. 1.08. What is the ratio of the Expenses (% of total expenses) in Honduras in 2011 to that in 2012?
Keep it short and to the point. 0.99. What is the ratio of the Expenses (% of total expenses) of Nicaragua in 2011 to that in 2012?
Your answer should be very brief. 0.73. What is the ratio of the Expenses (% of total expenses) of Russian Federation in 2011 to that in 2012?
Offer a terse response. 1.15. What is the difference between the highest and the second highest Expenses (% of total expenses) in Croatia?
Keep it short and to the point. 0.75. What is the difference between the highest and the second highest Expenses (% of total expenses) in Honduras?
Your answer should be compact. 0.29. What is the difference between the highest and the second highest Expenses (% of total expenses) in Nicaragua?
Make the answer very short. 0.85. What is the difference between the highest and the second highest Expenses (% of total expenses) in Russian Federation?
Your answer should be very brief. 3.56. What is the difference between the highest and the lowest Expenses (% of total expenses) of Croatia?
Your answer should be very brief. 2.6. What is the difference between the highest and the lowest Expenses (% of total expenses) in Honduras?
Ensure brevity in your answer.  8.45. What is the difference between the highest and the lowest Expenses (% of total expenses) in Nicaragua?
Provide a succinct answer. 2.48. What is the difference between the highest and the lowest Expenses (% of total expenses) of Russian Federation?
Provide a succinct answer. 11.54. 